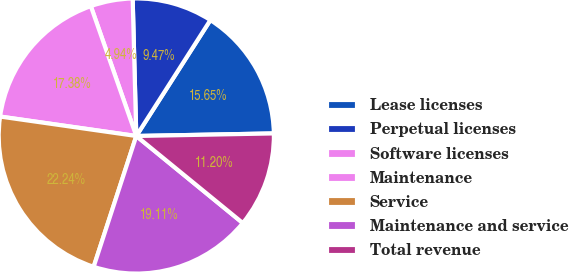Convert chart. <chart><loc_0><loc_0><loc_500><loc_500><pie_chart><fcel>Lease licenses<fcel>Perpetual licenses<fcel>Software licenses<fcel>Maintenance<fcel>Service<fcel>Maintenance and service<fcel>Total revenue<nl><fcel>15.65%<fcel>9.47%<fcel>4.94%<fcel>17.38%<fcel>22.24%<fcel>19.11%<fcel>11.2%<nl></chart> 